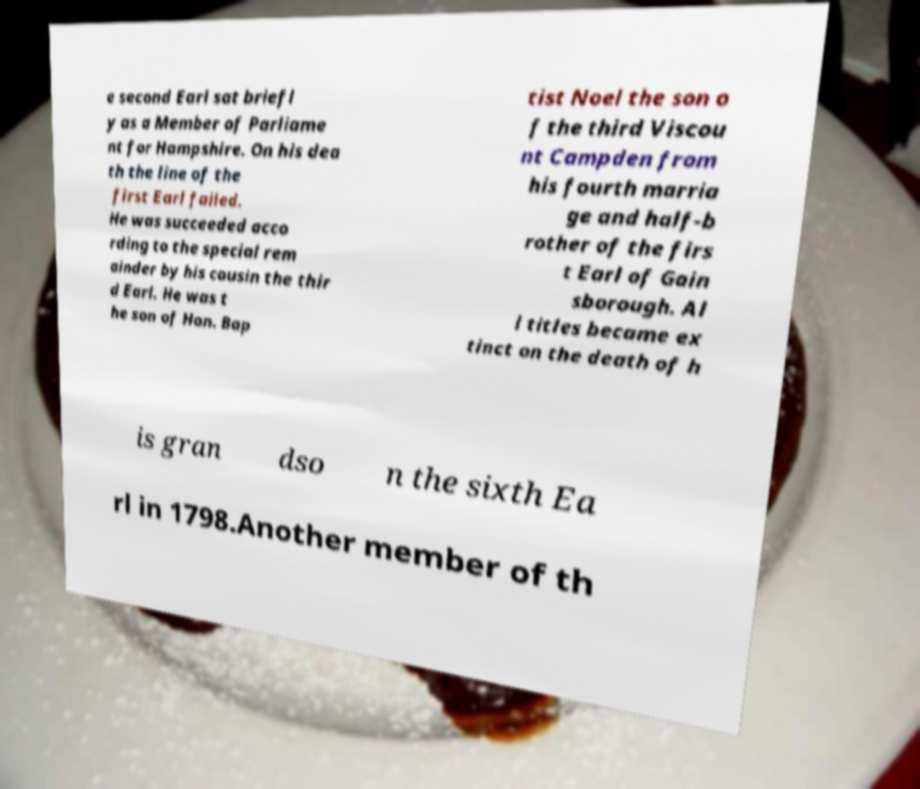There's text embedded in this image that I need extracted. Can you transcribe it verbatim? e second Earl sat briefl y as a Member of Parliame nt for Hampshire. On his dea th the line of the first Earl failed. He was succeeded acco rding to the special rem ainder by his cousin the thir d Earl. He was t he son of Hon. Bap tist Noel the son o f the third Viscou nt Campden from his fourth marria ge and half-b rother of the firs t Earl of Gain sborough. Al l titles became ex tinct on the death of h is gran dso n the sixth Ea rl in 1798.Another member of th 